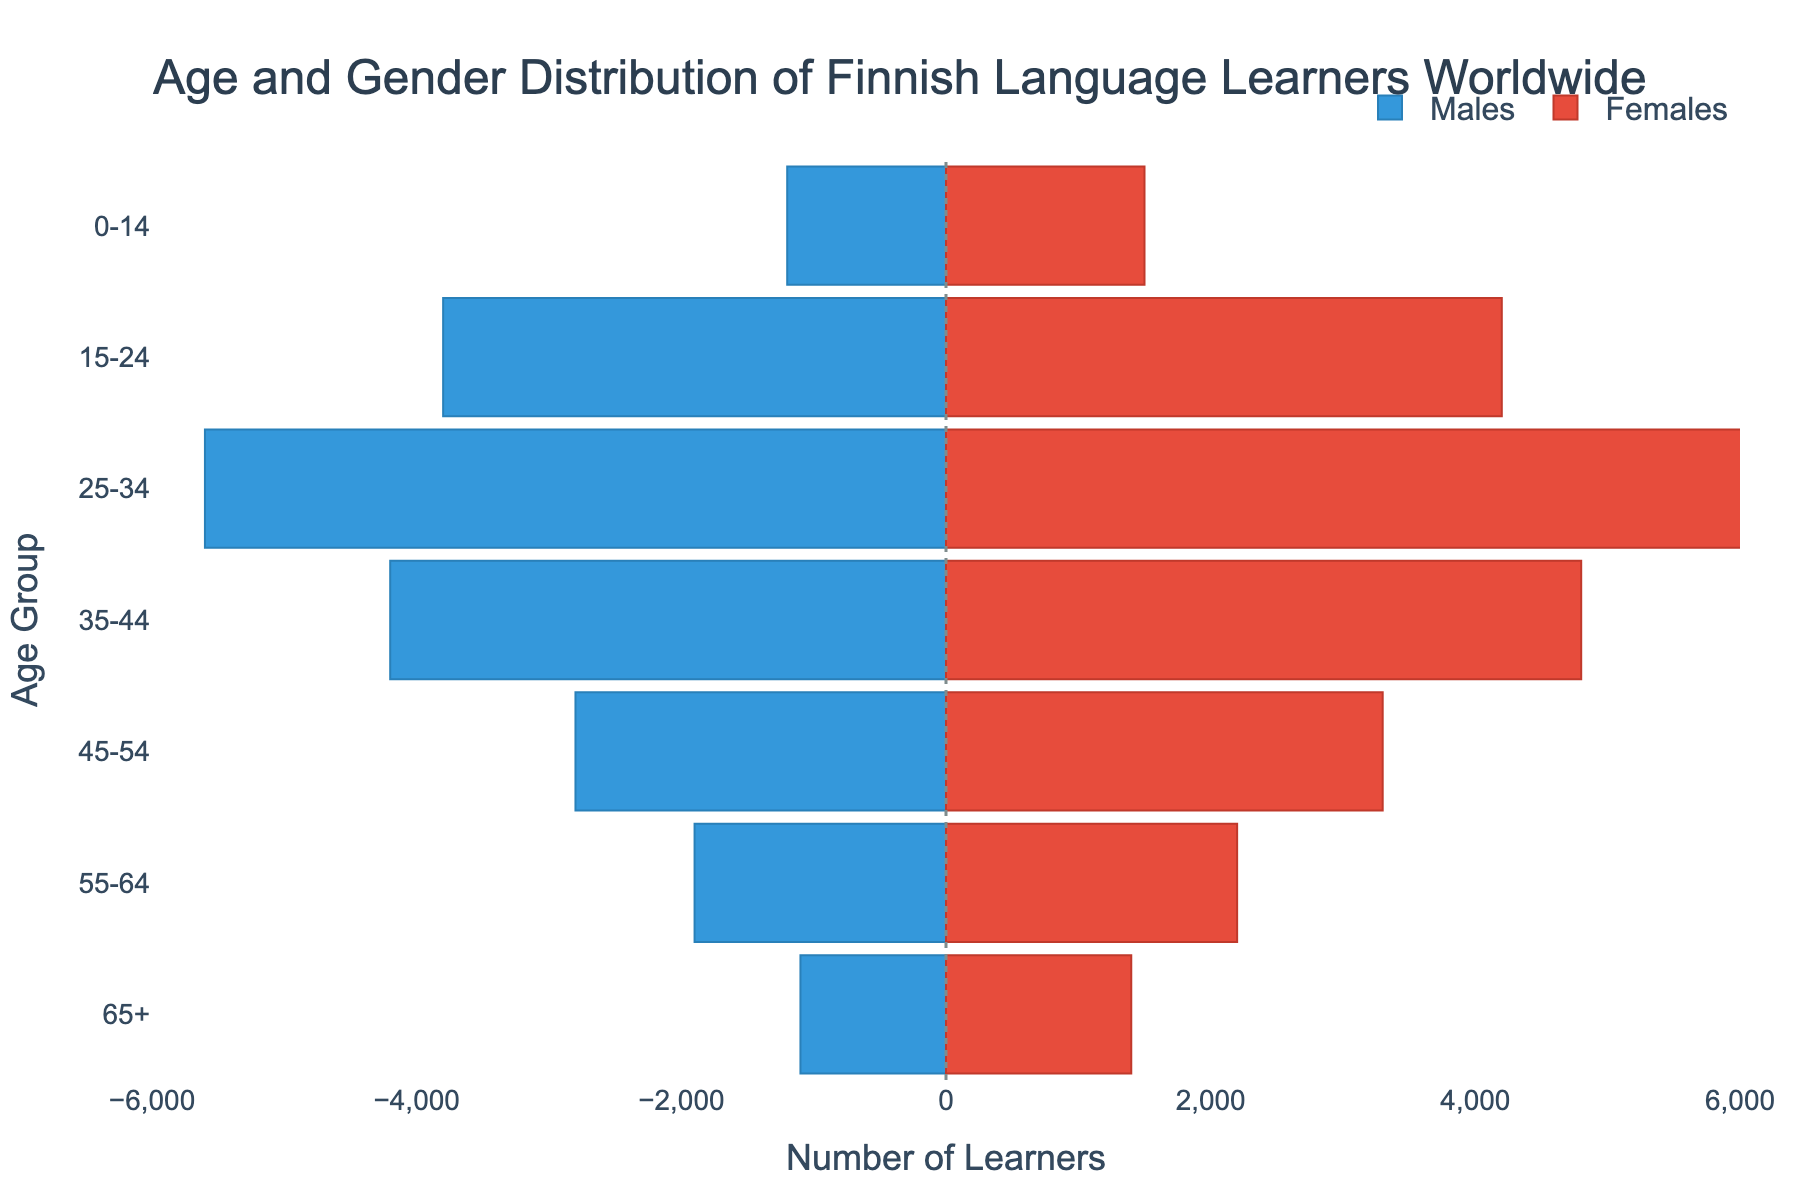What is the age group with the highest number of female Finnish language learners? Looking at the bar chart, the age group with the largest female bar is 25-34.
Answer: 25-34 How many male learners are there in the age group 0-14? The male bar for the 0-14 age group has a value of -1200, indicating 1200 male learners.
Answer: 1200 What is the total number of learners (male and female) in the age group 65+? Adding the number of male and female learners in the 65+ age group: 1100 males and 1400 females. So, 1100 + 1400 = 2500.
Answer: 2500 Which gender has more learners in the age group 45-54? Comparing the lengths of the male and female bars in the 45-54 age group, the female bar is longer with 3300 learners compared to 2800 male learners.
Answer: Female What is the difference between the number of male and female learners in the 15-24 age group? Subtracting the number of female learners from the number of male learners in the 15-24 age group: 4200 females - 3800 males = 400.
Answer: 400 Which age group has the smallest total number of learners? Comparing the combined lengths of bars for all age groups, the 0-14 age group has the smallest total: 1200 males + 1500 females = 2700, which is the lowest among all groups.
Answer: 0-14 How does the number of male learners in the 35-44 age group compare with the number of female learners in the same age group? The number of male learners in the 35-44 age group is 4200, while the number of female learners is 4800. So, females have more learners.
Answer: More females What is the proportion of female learners in the 55-64 age group compared to the total learners in that age group? The total number of learners in the 55-64 age group is 1900 males + 2200 females = 4100. The proportion of females is 2200 / 4100 ≈ 0.536 or about 53.6%.
Answer: 53.6% Which age group has the largest gender gap in Finnish language learners? By calculating the difference between male and female learners for each age group, the largest gap is in the 25-34 age group: 6100 females - 5600 males = 500.
Answer: 25-34 In the 0-14 age group, what percentage of the learners are male? The total number of learners in the 0-14 age group is 1200 males + 1500 females = 2700. The percentage of male learners is (1200 / 2700) * 100 ≈ 44.44%.
Answer: 44.44% 